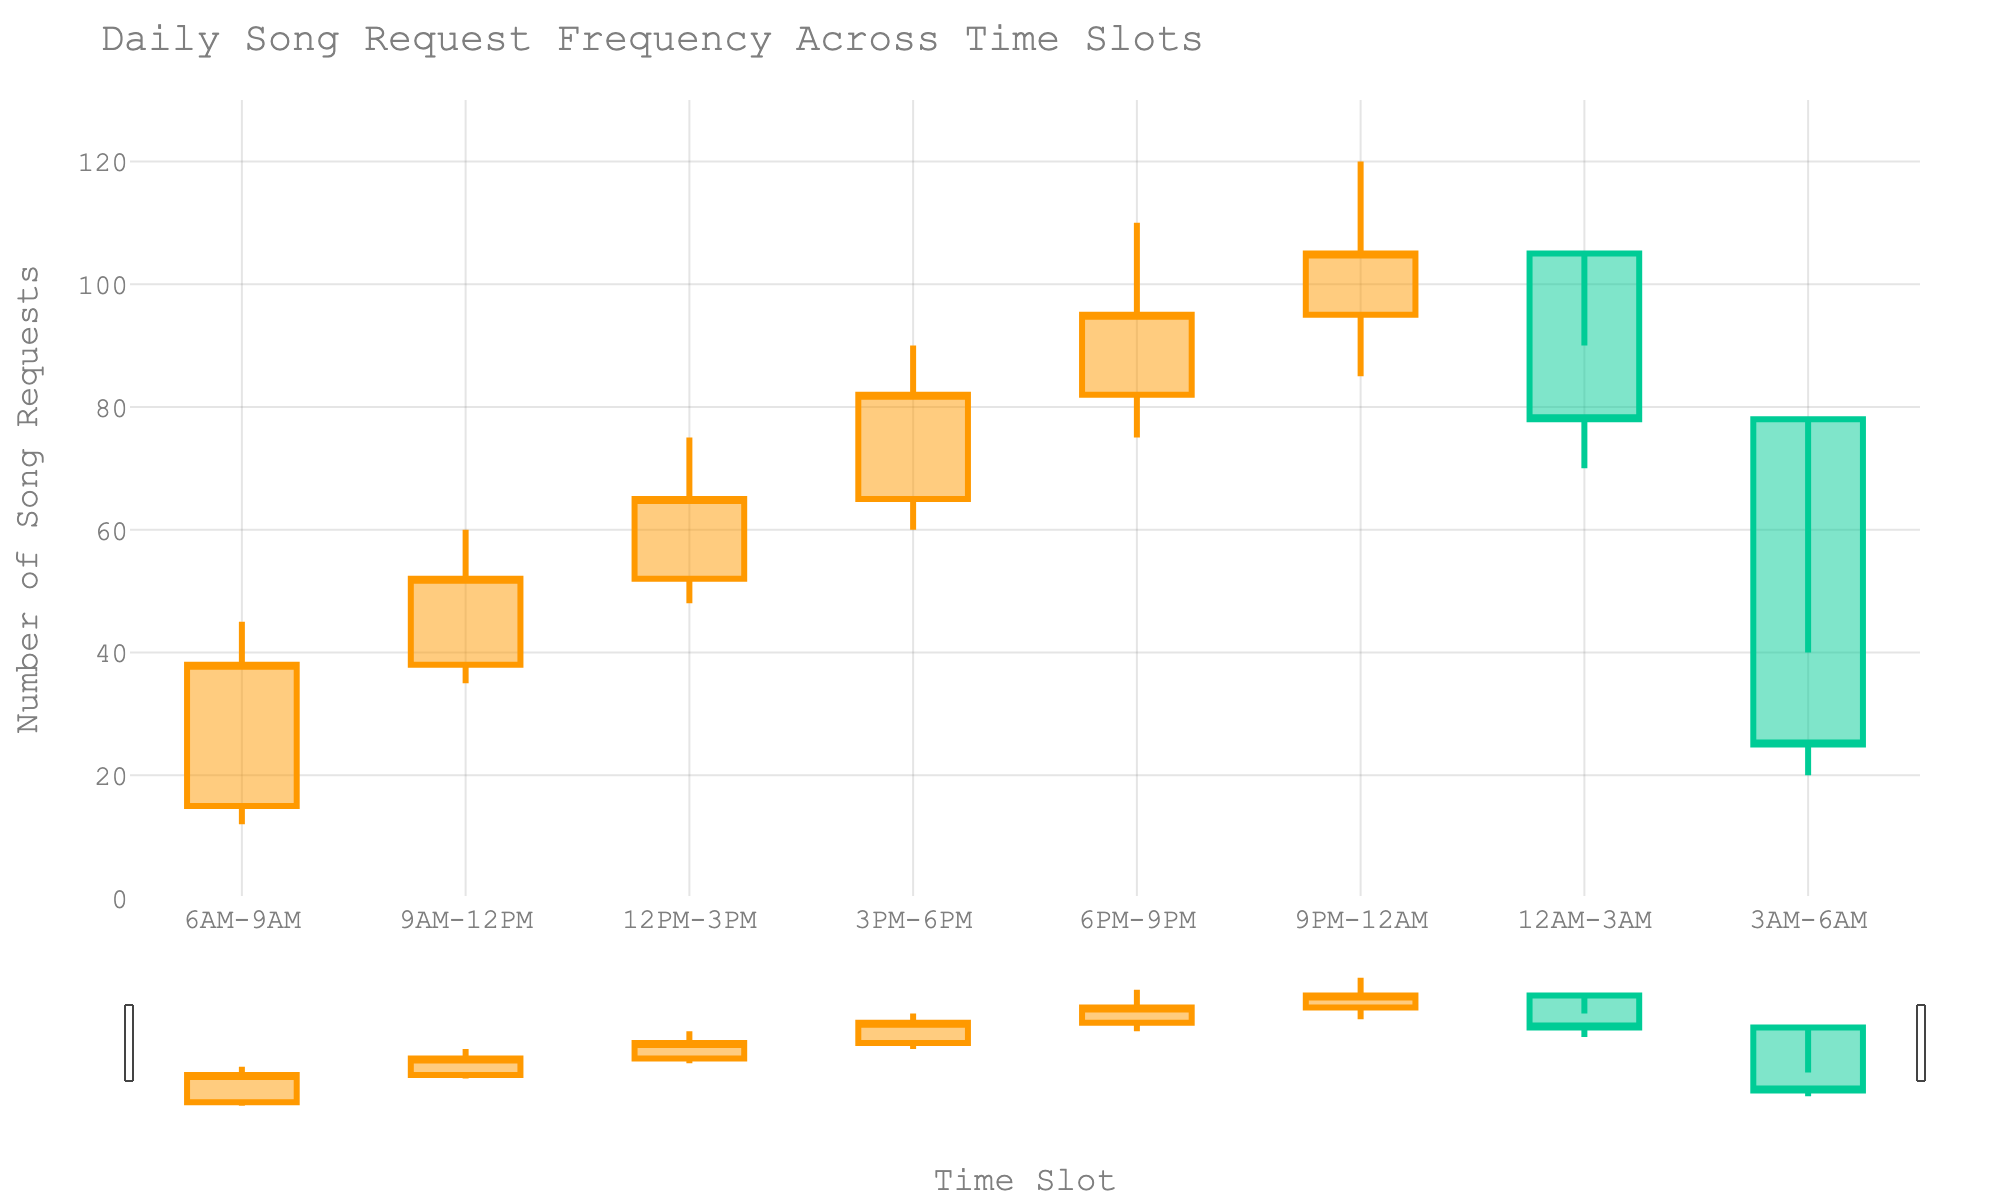What is the title of the chart? The title is usually located at the top of the chart and states the purpose or the main subject of the data.
Answer: Daily Song Request Frequency Across Time Slots How many time slots are displayed on the chart? Count the labels along the x-axis, each representing a distinct time slot.
Answer: 8 Which time slot has the highest number of song requests? Look at the highest "High" value in the OHLC chart which is indicated by the top of the candlestick. In this case, it's during the 9PM-12AM slot which reaches 120 requests.
Answer: 9PM-12AM At which time slots did the number of song requests increase by the end of the period? For an increase in requests, the “Close” value should be higher than the “Open” value. The time slots that meet this criterion are 6AM-9AM, 9AM-12PM, 12PM-3PM, 3PM-6PM, 6PM-9PM, and 9PM-12AM.
Answer: 6AM-9AM, 9AM-12PM, 12PM-3PM, 3PM-6PM, 6PM-9PM, and 9PM-12AM During which time slot did the number of requests decrease the most? Identify the slot where the difference between the Open and Close values is the largest in a decreasing direction. This occurs between 12AM-3AM where it drops from 105 to 78, a difference of 27.
Answer: 12AM-3AM Which time slot shows a dramatic drop in song requests? The time slot 3AM-6AM shows a steep decline from an Open value of 78 to a Close value of 25, which is a dramatic drop of 53 requests.
Answer: 3AM-6AM Compare the time slots 3PM-6PM and 12PM-3PM. Which time slot has a higher Open value? The Open value of 3PM-6PM is 65, while for 12PM-3PM it is 52, thus 3PM-6PM has a higher opening value.
Answer: 3PM-6PM What is the average "High" value across all time slots? Sum all the “High” values and divide by the number of time slots. This is (45+60+75+90+110+120+90+40)/8 = 78.75
Answer: 78.75 Which time slot has the smallest difference between its High and Low values? Find the slot where the difference between the High and Low is least. For the 6AM-9AM slot, the difference is 45-12=33, for the 9AM-12PM slot, it is 60-35=25, and so on. The smallest difference is during the 9AM-12PM slot, which is 25.
Answer: 9AM-12PM During which time slot does the chart show no increase from the Open value to the Close value? Check each time slot's Open and Close values. The only slot where the Open and Close values don't show an increase is 3AM-6AM (78 to 25).
Answer: 3AM-6AM 